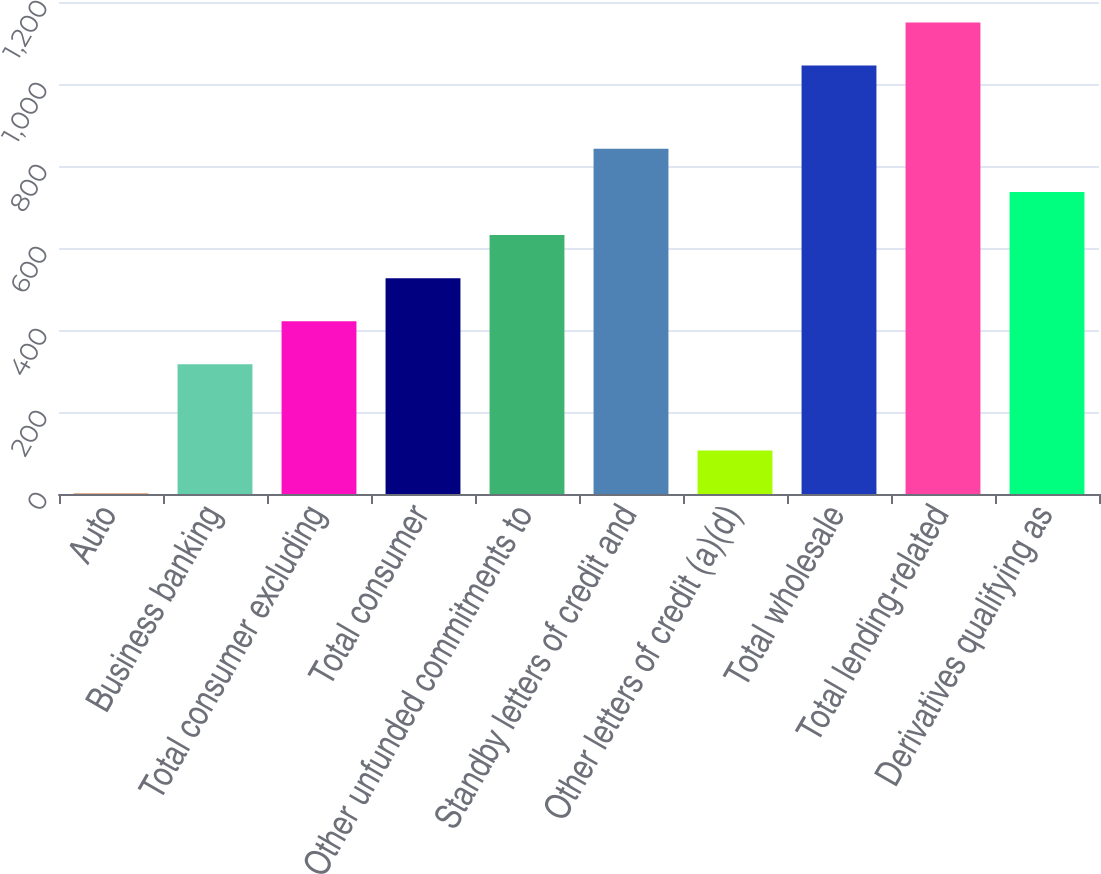<chart> <loc_0><loc_0><loc_500><loc_500><bar_chart><fcel>Auto<fcel>Business banking<fcel>Total consumer excluding<fcel>Total consumer<fcel>Other unfunded commitments to<fcel>Standby letters of credit and<fcel>Other letters of credit (a)(d)<fcel>Total wholesale<fcel>Total lending-related<fcel>Derivatives qualifying as<nl><fcel>1<fcel>316.3<fcel>421.4<fcel>526.5<fcel>631.6<fcel>841.8<fcel>106.1<fcel>1045<fcel>1150.1<fcel>736.7<nl></chart> 